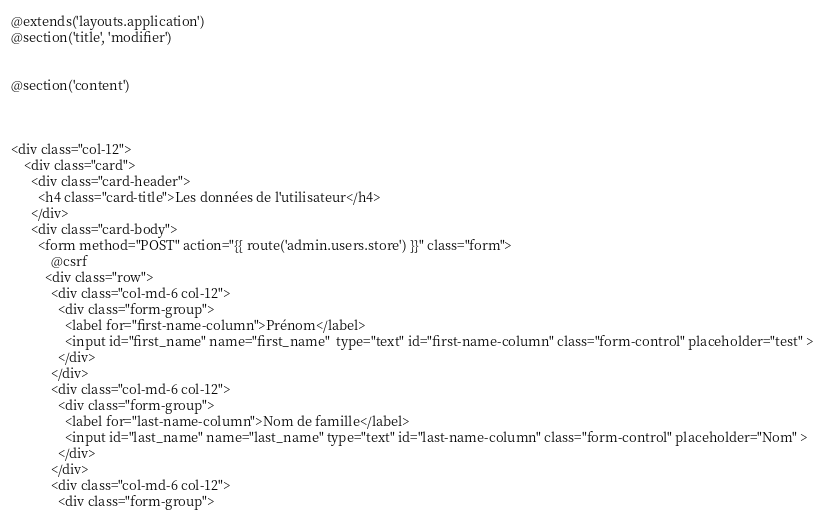<code> <loc_0><loc_0><loc_500><loc_500><_PHP_>@extends('layouts.application')
@section('title', 'modifier')


@section('content')


   
<div class="col-12">
    <div class="card">
      <div class="card-header">
        <h4 class="card-title">Les données de l'utilisateur</h4>
      </div>
      <div class="card-body">
        <form method="POST" action="{{ route('admin.users.store') }}" class="form">
            @csrf
          <div class="row">
            <div class="col-md-6 col-12">
              <div class="form-group">
                <label for="first-name-column">Prénom</label>
                <input id="first_name" name="first_name"  type="text" id="first-name-column" class="form-control" placeholder="test" >
              </div>
            </div>
            <div class="col-md-6 col-12">
              <div class="form-group">
                <label for="last-name-column">Nom de famille</label>
                <input id="last_name" name="last_name" type="text" id="last-name-column" class="form-control" placeholder="Nom" >
              </div>
            </div>
            <div class="col-md-6 col-12">
              <div class="form-group"></code> 